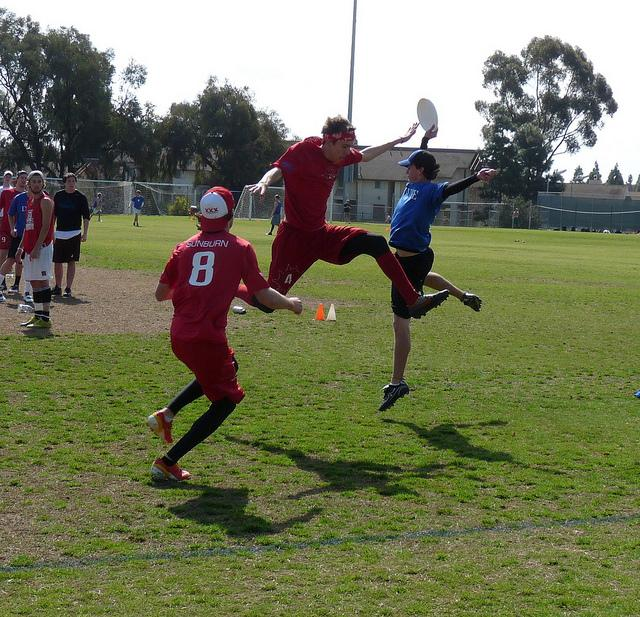What word rhymes with the number on the man's shirt?

Choices:
A) hate
B) boo
C) more
D) fine hate 